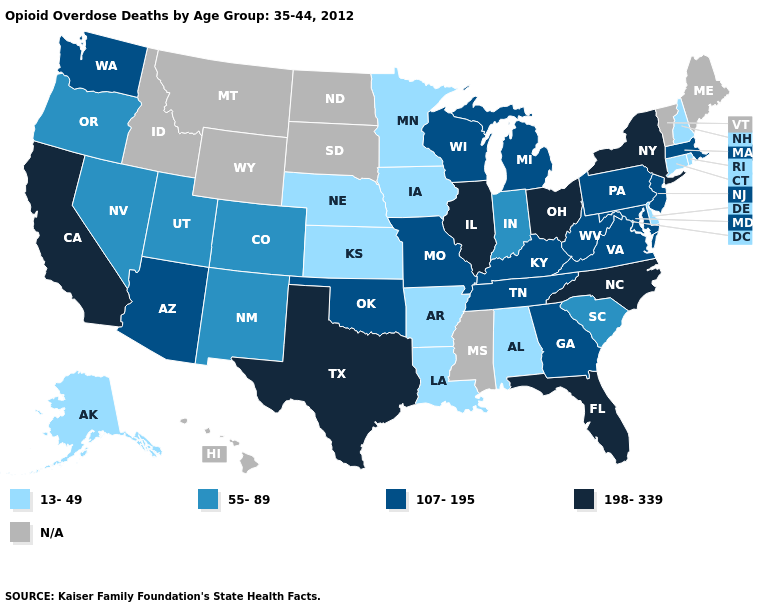What is the value of Missouri?
Concise answer only. 107-195. Among the states that border Pennsylvania , does New York have the highest value?
Be succinct. Yes. Name the states that have a value in the range N/A?
Concise answer only. Hawaii, Idaho, Maine, Mississippi, Montana, North Dakota, South Dakota, Vermont, Wyoming. Name the states that have a value in the range N/A?
Write a very short answer. Hawaii, Idaho, Maine, Mississippi, Montana, North Dakota, South Dakota, Vermont, Wyoming. What is the value of Idaho?
Be succinct. N/A. Among the states that border Connecticut , which have the highest value?
Concise answer only. New York. Name the states that have a value in the range 13-49?
Answer briefly. Alabama, Alaska, Arkansas, Connecticut, Delaware, Iowa, Kansas, Louisiana, Minnesota, Nebraska, New Hampshire, Rhode Island. What is the highest value in the South ?
Quick response, please. 198-339. Among the states that border Maryland , which have the highest value?
Be succinct. Pennsylvania, Virginia, West Virginia. Name the states that have a value in the range 198-339?
Concise answer only. California, Florida, Illinois, New York, North Carolina, Ohio, Texas. Name the states that have a value in the range N/A?
Write a very short answer. Hawaii, Idaho, Maine, Mississippi, Montana, North Dakota, South Dakota, Vermont, Wyoming. What is the value of Florida?
Keep it brief. 198-339. How many symbols are there in the legend?
Quick response, please. 5. 